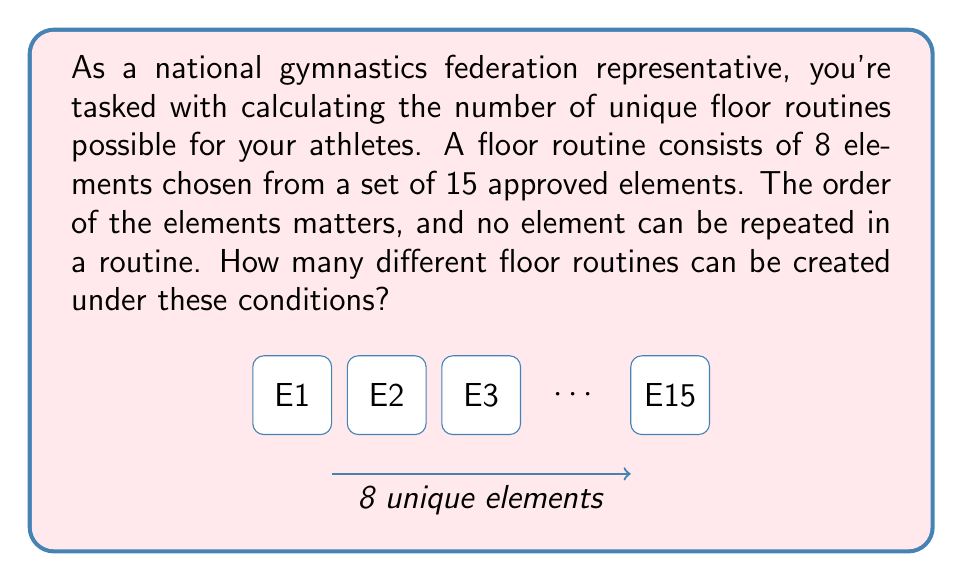Can you answer this question? Let's approach this step-by-step:

1) This is a permutation problem. We are selecting 8 elements out of 15, where order matters and repetition is not allowed.

2) The formula for permutations without repetition is:

   $$P(n,r) = \frac{n!}{(n-r)!}$$

   Where $n$ is the total number of items to choose from, and $r$ is the number of items being chosen.

3) In this case, $n = 15$ (total approved elements) and $r = 8$ (elements in a routine).

4) Plugging these values into our formula:

   $$P(15,8) = \frac{15!}{(15-8)!} = \frac{15!}{7!}$$

5) Expand this:
   $$\frac{15 \times 14 \times 13 \times 12 \times 11 \times 10 \times 9 \times 8 \times 7!}{7!}$$

6) The 7! cancels out in the numerator and denominator:

   $$15 \times 14 \times 13 \times 12 \times 11 \times 10 \times 9 \times 8 = 1,816,214,400$$

Therefore, there are 1,816,214,400 possible unique floor routines.
Answer: 1,816,214,400 